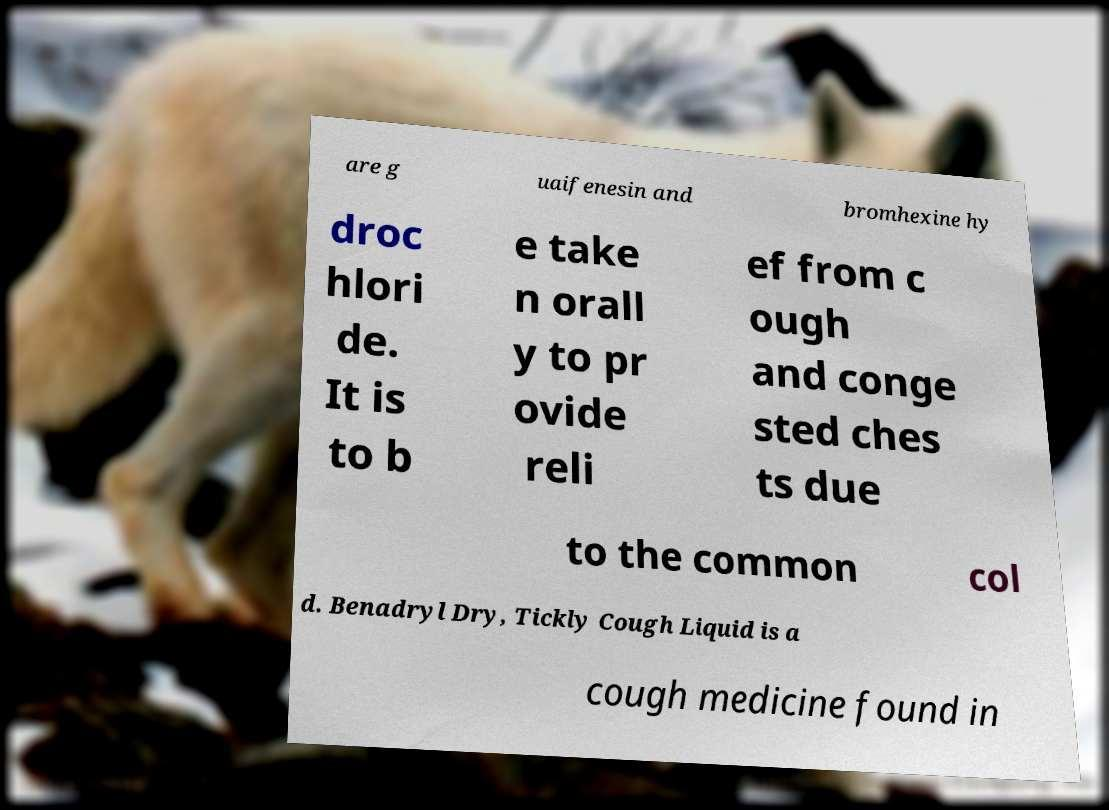Can you accurately transcribe the text from the provided image for me? are g uaifenesin and bromhexine hy droc hlori de. It is to b e take n orall y to pr ovide reli ef from c ough and conge sted ches ts due to the common col d. Benadryl Dry, Tickly Cough Liquid is a cough medicine found in 